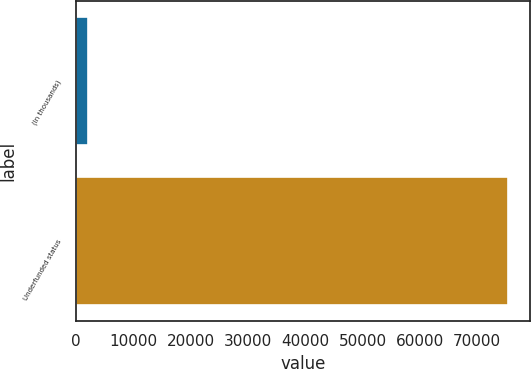Convert chart to OTSL. <chart><loc_0><loc_0><loc_500><loc_500><bar_chart><fcel>(In thousands)<fcel>Underfunded status<nl><fcel>2017<fcel>75485<nl></chart> 